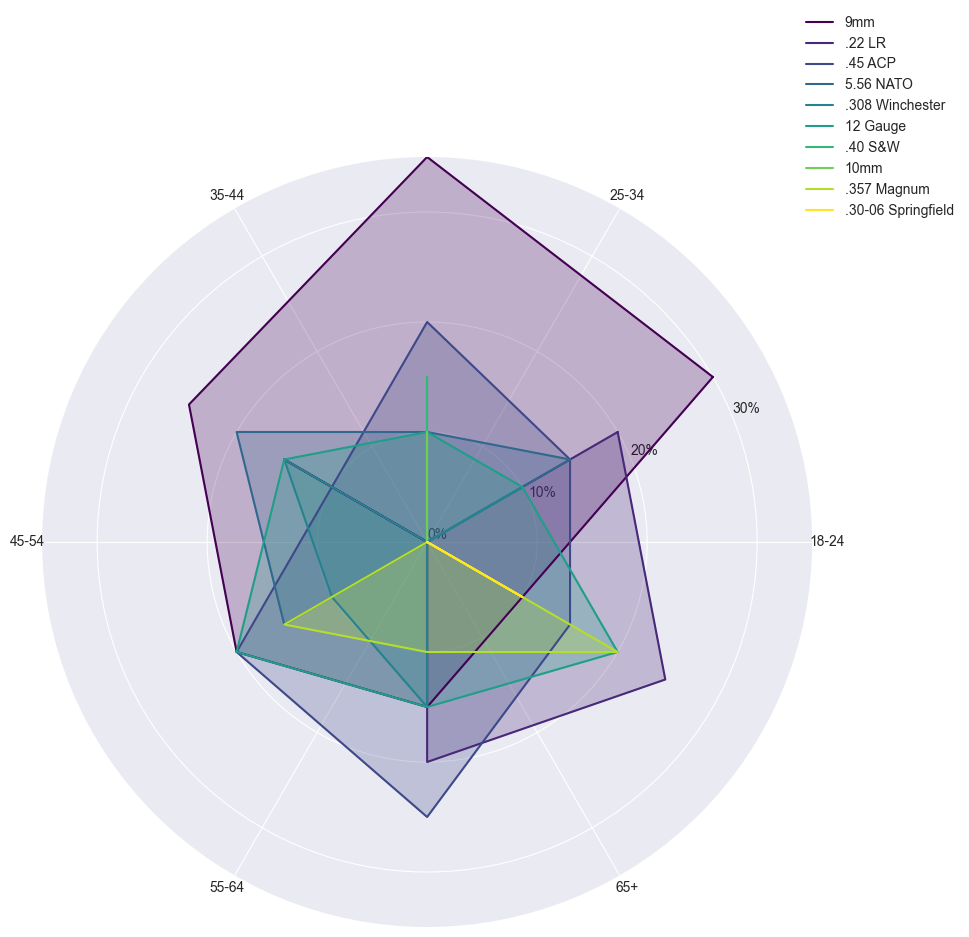what caliber is the least preferred by the 18-24 age group? To determine the least preferred caliber for the 18-24 age group, we look at the data for this age group and identify the caliber with the lowest percentage. The least preferred caliber is tied between .308 Winchester and 12 Gauge, both at 10%.
Answer: .308 Winchester and 12 Gauge Which age group prefers the 9mm caliber the most? To find which age group prefers the 9mm caliber the most, check the percentage values for 9mm across all age groups. The 25-34 age group has the highest preference for the 9mm caliber at 35%.
Answer: 25-34 Among the calibers .22 LR, 5.56 NATO, and .45 ACP, which one is most preferred by the 35-44 age group? Compare the percentages of .22 LR, 5.56 NATO, and .45 ACP within the 35-44 age group. .22 LR is 15%, 5.56 NATO is 20%, and .45 ACP is 10%. The most preferred caliber among these is 5.56 NATO at 20%.
Answer: 5.56 NATO What is the total percentage of buyers aged 18-24 who prefer either 9mm or .45 ACP? Sum the percentages of buyers aged 18-24 who prefer the 9mm and .45 ACP calibers. 9mm is 30% and .45 ACP is 15%. Summing these gives 30% + 15% = 45%.
Answer: 45% Which age group shows an increasing trend in preference for the .45 ACP caliber as the age increases? Check the percentages for .45 ACP across different age groups: 18-24 (15%), 25-34 (20%), 35-44 (10%), 45-54 (20%), and 55-64 (25%). Notice an increasing trend from 18 to 64: 15%, 20%, and 25%. The 65+ group breaks this trend with 15%.
Answer: 55-64 How does the preference for the 12 Gauge caliber compare between the 45-54 and 55-64 age groups? Compare the preference percentages for the 12 Gauge caliber between the 45-54 and 55-64 age groups. For 45-54, it is 20%, and for 55-64, it is 15%. The 45-54 age group prefers the 12 Gauge caliber more.
Answer: 45-54 prefers more What is the most preferred caliber for buyers aged 65 and older? Look at the preferences for all calibers in the 65+ age group. The .22 LR caliber is the most preferred with a percentage of 25%.
Answer: .22 LR Which age group has an equal preference for the .308 Winchester and 12 Gauge calibers, and what is the percentage? Identify the age group with equal percentages for both calibers by checking the data. The 35-44 age group has an equal percentage of 15% for both .308 Winchester and 12 Gauge.
Answer: 35-44, 15% Is there any age group that has an equal preference for two different calibers greater than 20%? Review all age groups to find any with equal preferences higher than 20%. The 55-64 age group has a 25% preference for both .45 ACP and .22 LR.
Answer: 55-64, 25% What is the average percentage preference for the .357 Magnum caliber among all age groups? Calculate the average percentage preference of the .357 Magnum caliber by summing the percentages across all age groups and dividing by the number of age groups: (0% + 0% + 0% + 15% + 10% + 20%) / 6 = 7.5%.
Answer: 7.5% 